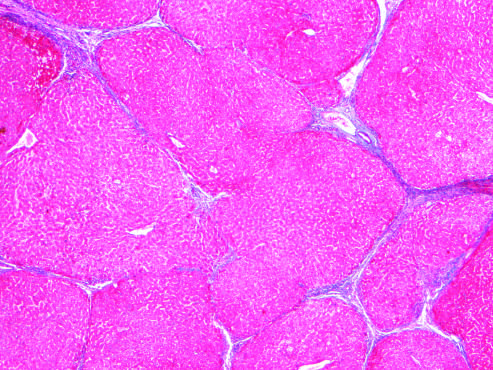re most scars gone after 1 year of abstinence?
Answer the question using a single word or phrase. Yes 